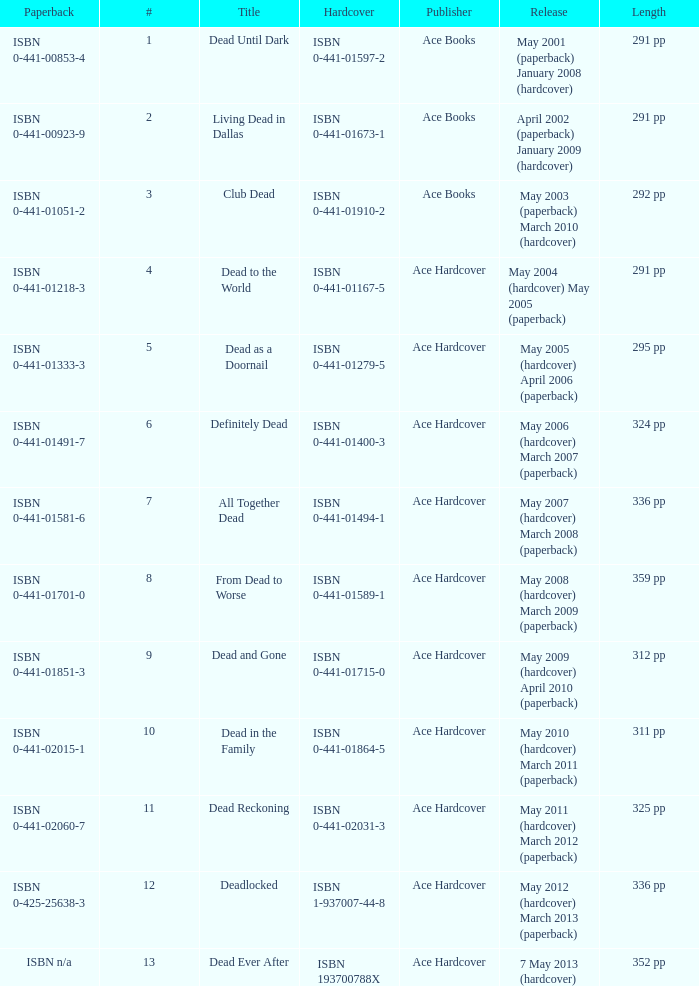Who pubilshed isbn 1-937007-44-8? Ace Hardcover. 